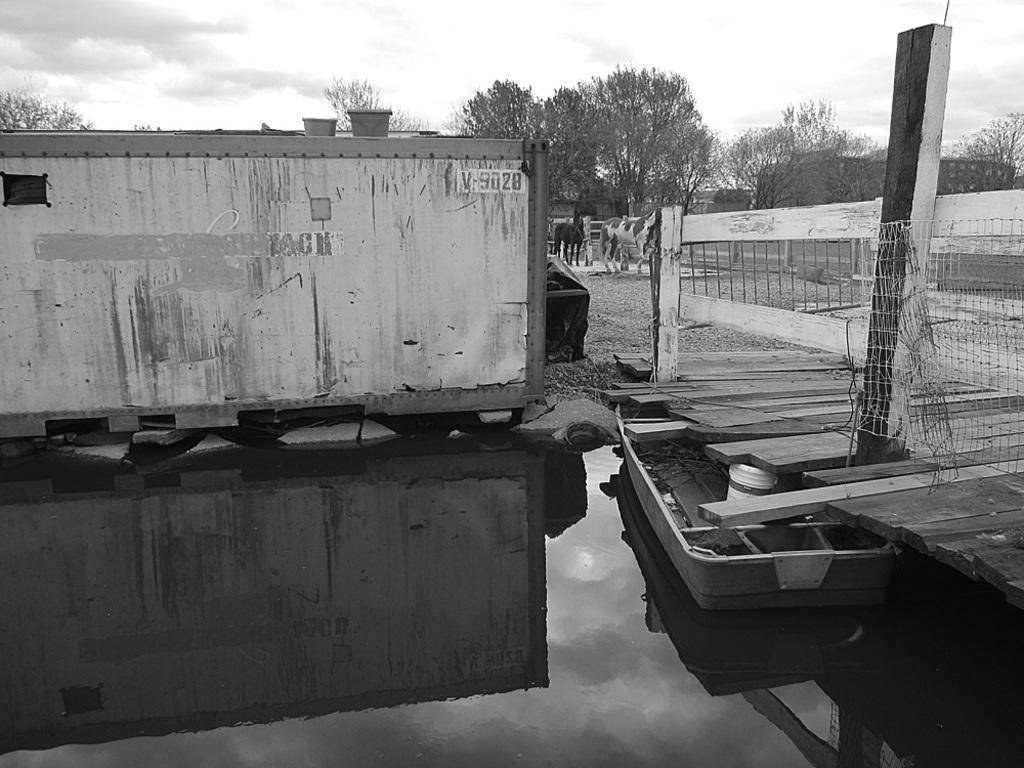In one or two sentences, can you explain what this image depicts? In this image we can see an object looks like a container, there is a boat on the water, a bridge, fence, an object beside the container, in the background there are few animals on the ground, trees and the sky. 